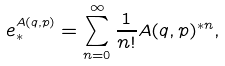<formula> <loc_0><loc_0><loc_500><loc_500>e _ { * } ^ { A ( q , p ) } = \sum _ { n = 0 } ^ { \infty } \frac { 1 } { n ! } A ( q , p ) ^ { * n } ,</formula> 